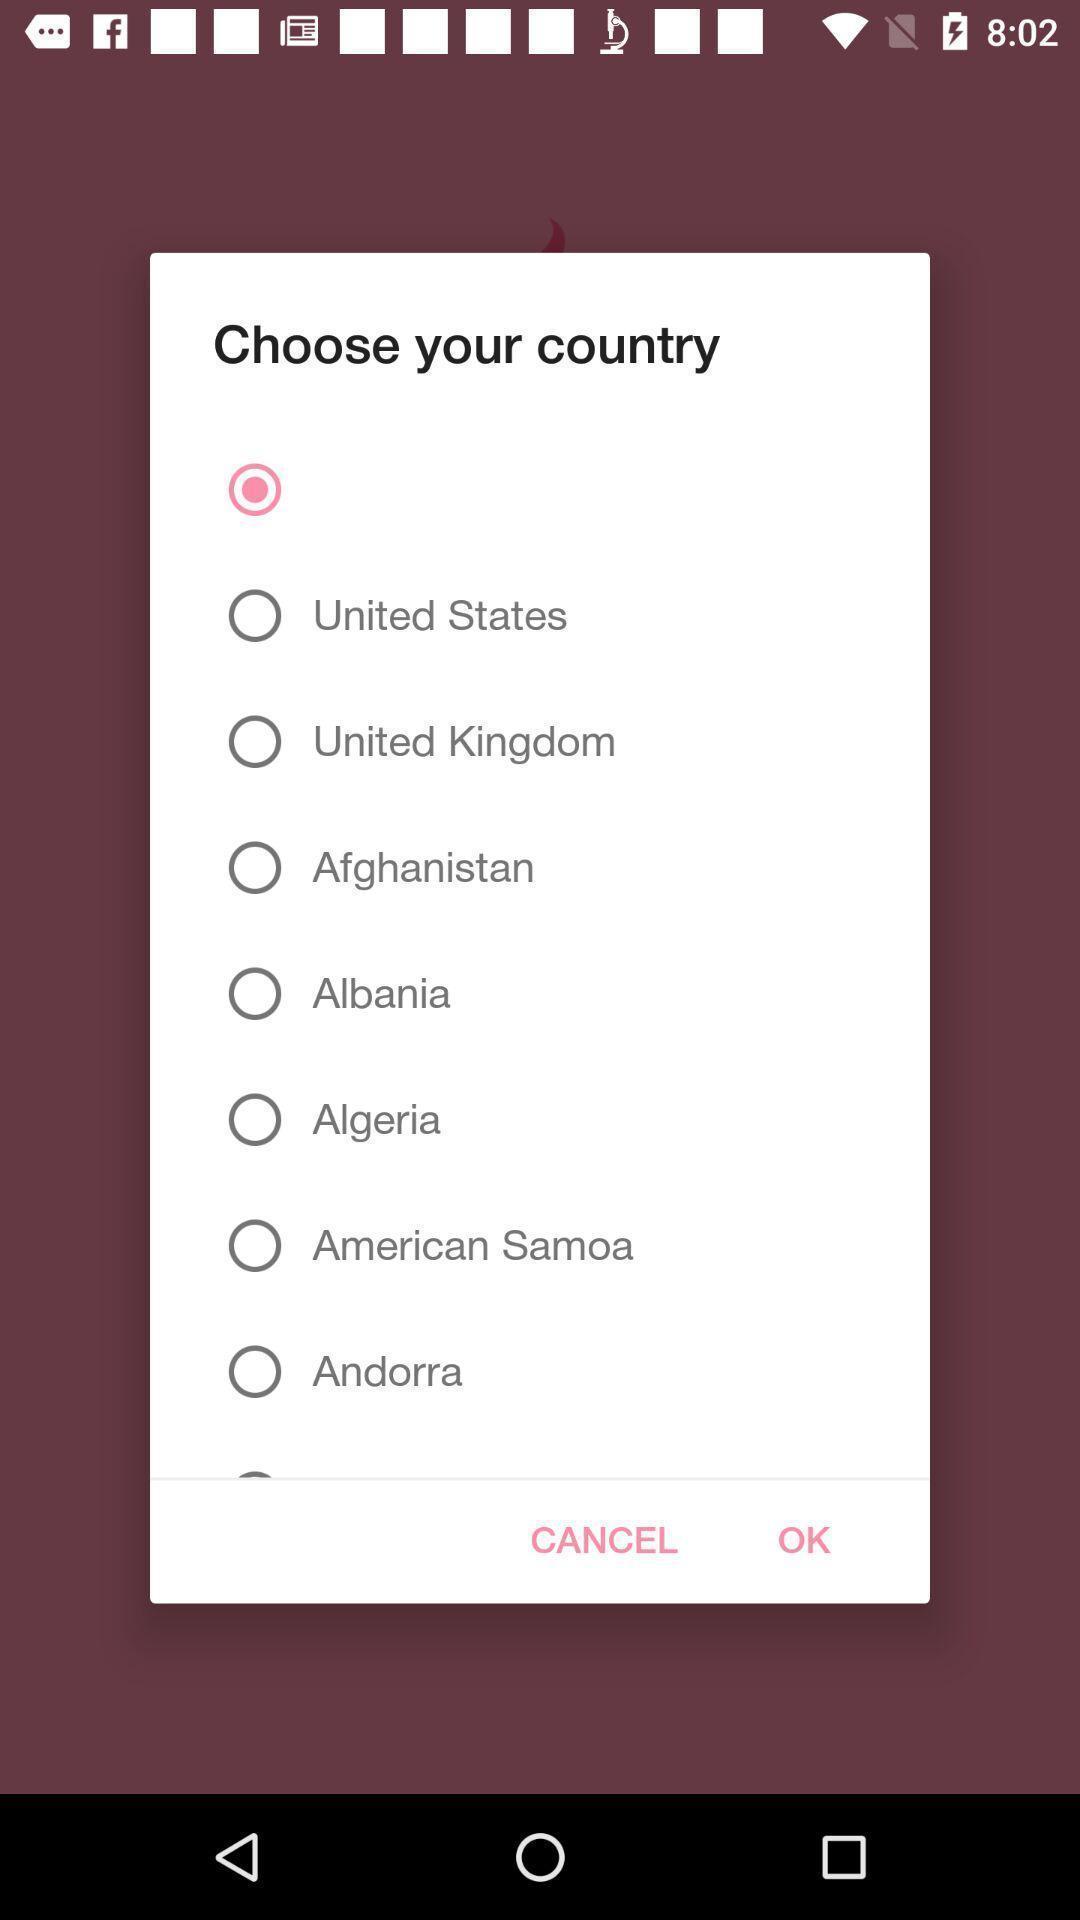What details can you identify in this image? Pop-up with list of country options to choose one. 